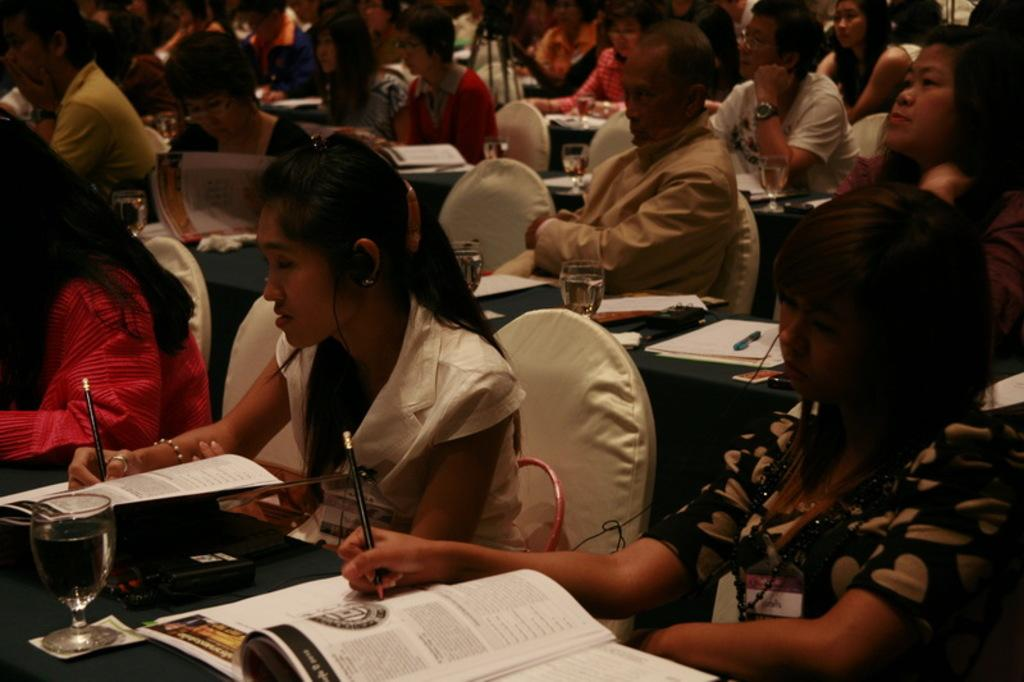How many people are in the image? There is a group of people in the image. What are the people doing in the image? The people are sitting on chairs and writing on books. What tools are the people using to write? The people are using pencils. What items can be seen on the table in the image? There are glasses, books, a remote, papers, and a pen on the table. What type of apples are being served as a side dish with the stew in the image? There is no mention of apples or stew in the image; the focus is on the group of people writing on books and the items on the table. 